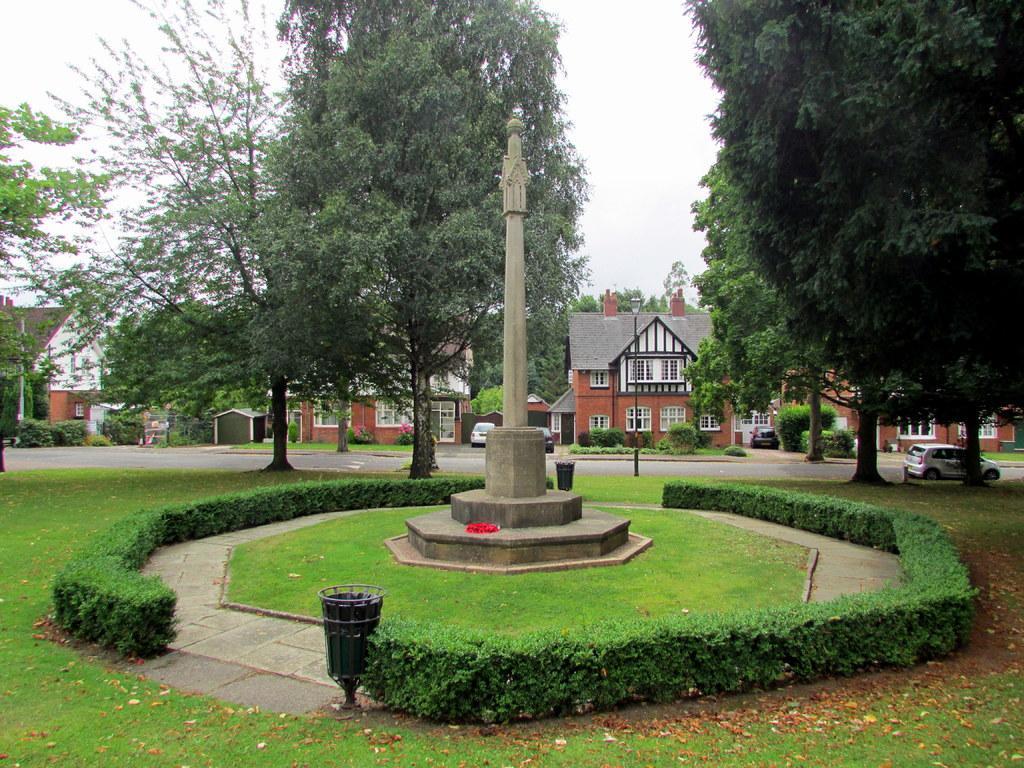How would you summarize this image in a sentence or two? This picture is clicked outside. In the foreground we can see the green grass and shrubs. In the center there is an object and we can see there are some items on the ground. In the center we can see the houses and the windows of the houses and we can see there are some vehicles seems to be parked on the road. In the background we can see the sky and trees. 